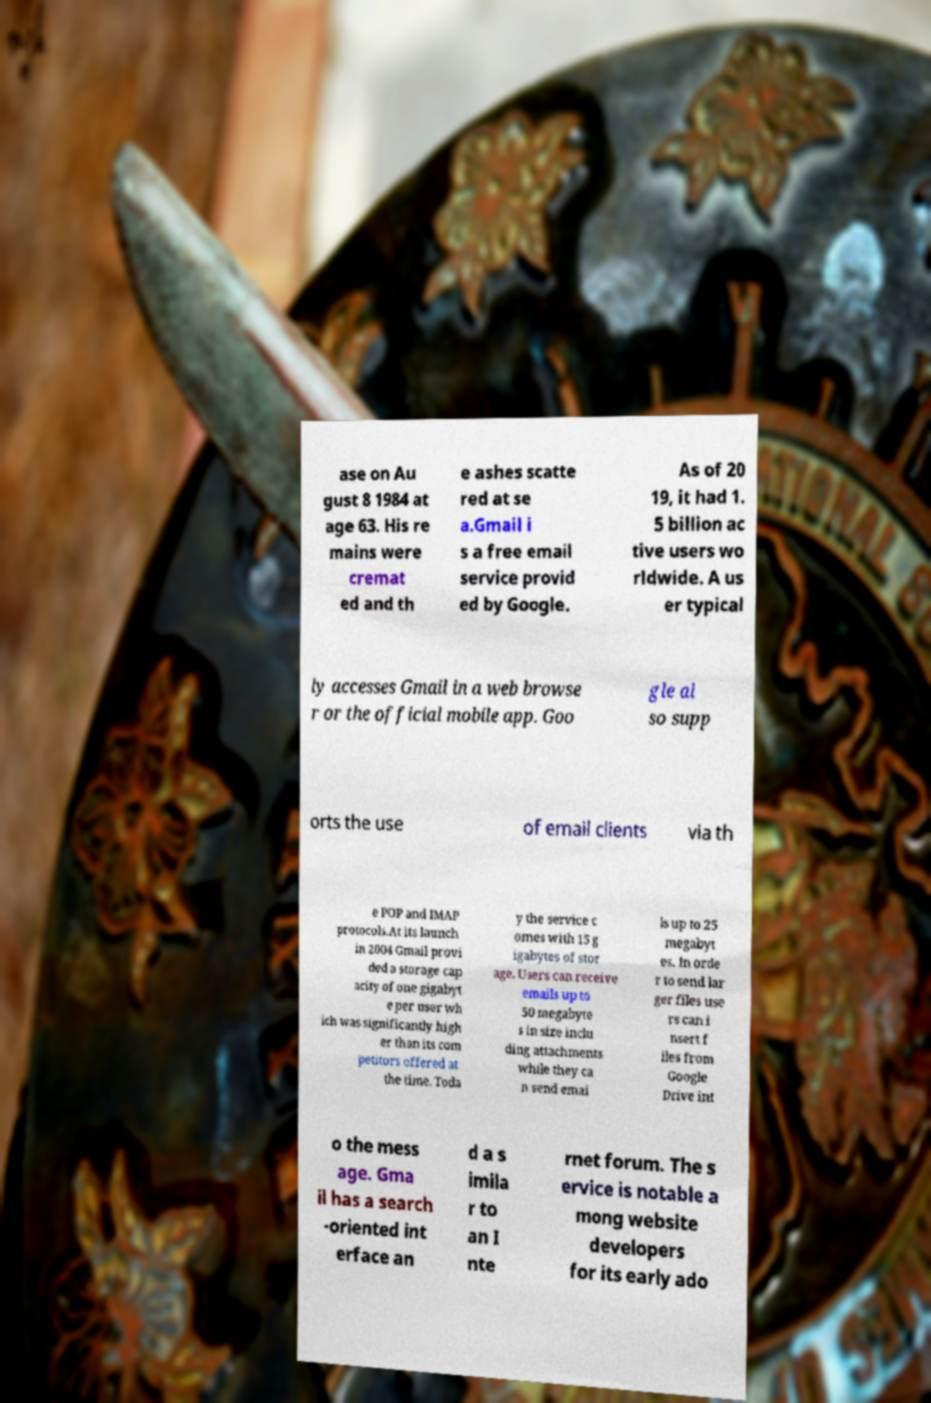Please read and relay the text visible in this image. What does it say? ase on Au gust 8 1984 at age 63. His re mains were cremat ed and th e ashes scatte red at se a.Gmail i s a free email service provid ed by Google. As of 20 19, it had 1. 5 billion ac tive users wo rldwide. A us er typical ly accesses Gmail in a web browse r or the official mobile app. Goo gle al so supp orts the use of email clients via th e POP and IMAP protocols.At its launch in 2004 Gmail provi ded a storage cap acity of one gigabyt e per user wh ich was significantly high er than its com petitors offered at the time. Toda y the service c omes with 15 g igabytes of stor age. Users can receive emails up to 50 megabyte s in size inclu ding attachments while they ca n send emai ls up to 25 megabyt es. In orde r to send lar ger files use rs can i nsert f iles from Google Drive int o the mess age. Gma il has a search -oriented int erface an d a s imila r to an I nte rnet forum. The s ervice is notable a mong website developers for its early ado 